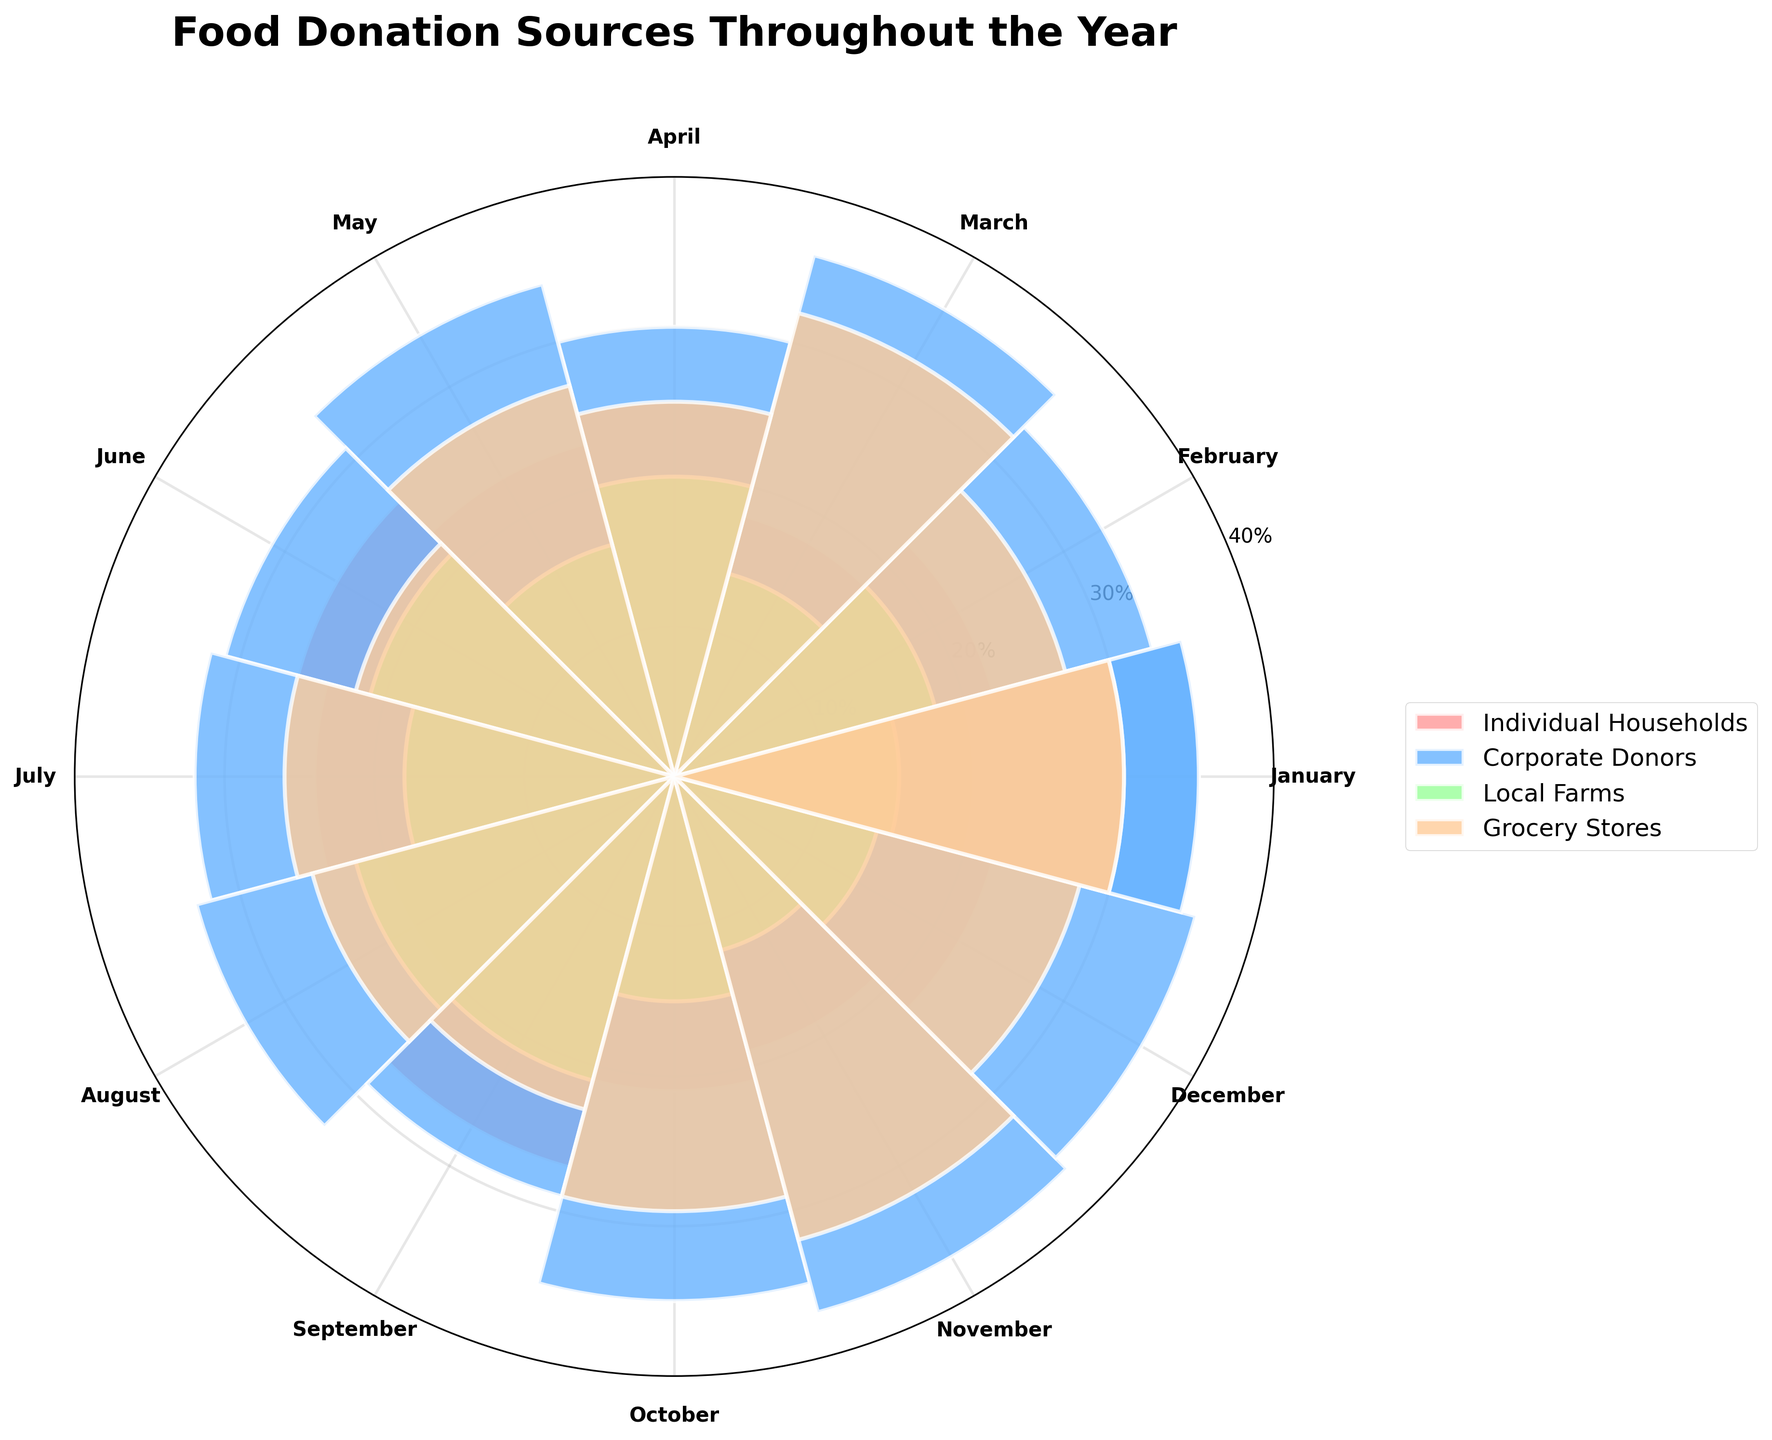How many sources of food donations are visualized in the plot? The plot shows a separate bar for each source of food donations, with each bar colored differently. By counting the unique colors or labels, you can determine the number of sources.
Answer: Four Which month shows the highest proportion of donations from Corporate Donors? The height of the bar segment representing Corporate Donors will vary across the months. By inspecting the highest bar segment across the months for Corporate Donors, the month with the tallest bar represents the highest proportion.
Answer: November What is the proportion range for donations from Local Farms throughout the year? By checking the maximum and minimum heights of the bars for the Local Farms across all months, you can deduce the range of proportions.
Answer: 0.12 to 0.22 (12% to 22%) During which month do Individual Households donate more than Grocery Stores? By comparing the height of the bars for Individual Households and Grocery Stores for each month, identify the months where the bar for Individual Households is taller than that for Grocery Stores.
Answer: April, June, July, September Which source has the most consistent donation proportion throughout the year? By visually inspecting the variation in bar heights for each source across all months, identify the source with the least variability in height.
Answer: Corporate Donors What's the overall trend of donations from Grocery Stores throughout the year? Is there a particular trend you observe? By looking at the bar heights for Grocery Stores from January to December, you can describe the overall pattern, such as increasing, decreasing, or fluctuating.
Answer: Fluctuating How does the donation proportion from Local Farms in May compare to that in November? By inspecting the height of the Local Farms' bars for May and November, and noting the values, you compare them directly.
Answer: Higher in May Which month has the highest combined proportion of donations from Local Farms and Grocery Stores? For each month, sum the bar heights for Local Farms and Grocery Stores, and identify the month with the highest combined value.
Answer: March Does any source's donation proportion exceed 35% in any month? If so, which source and in which month? Check each source's bar heights across all months, and identify if any value exceeds 35%.
Answer: Corporate Donors in November and December How do the proportions of donations from Corporate Donors and Individual Households compare in June? Compare the height of the bars for Corporate Donors and Individual Households for June by visually inspecting their respective values.
Answer: Corporate Donors are higher 